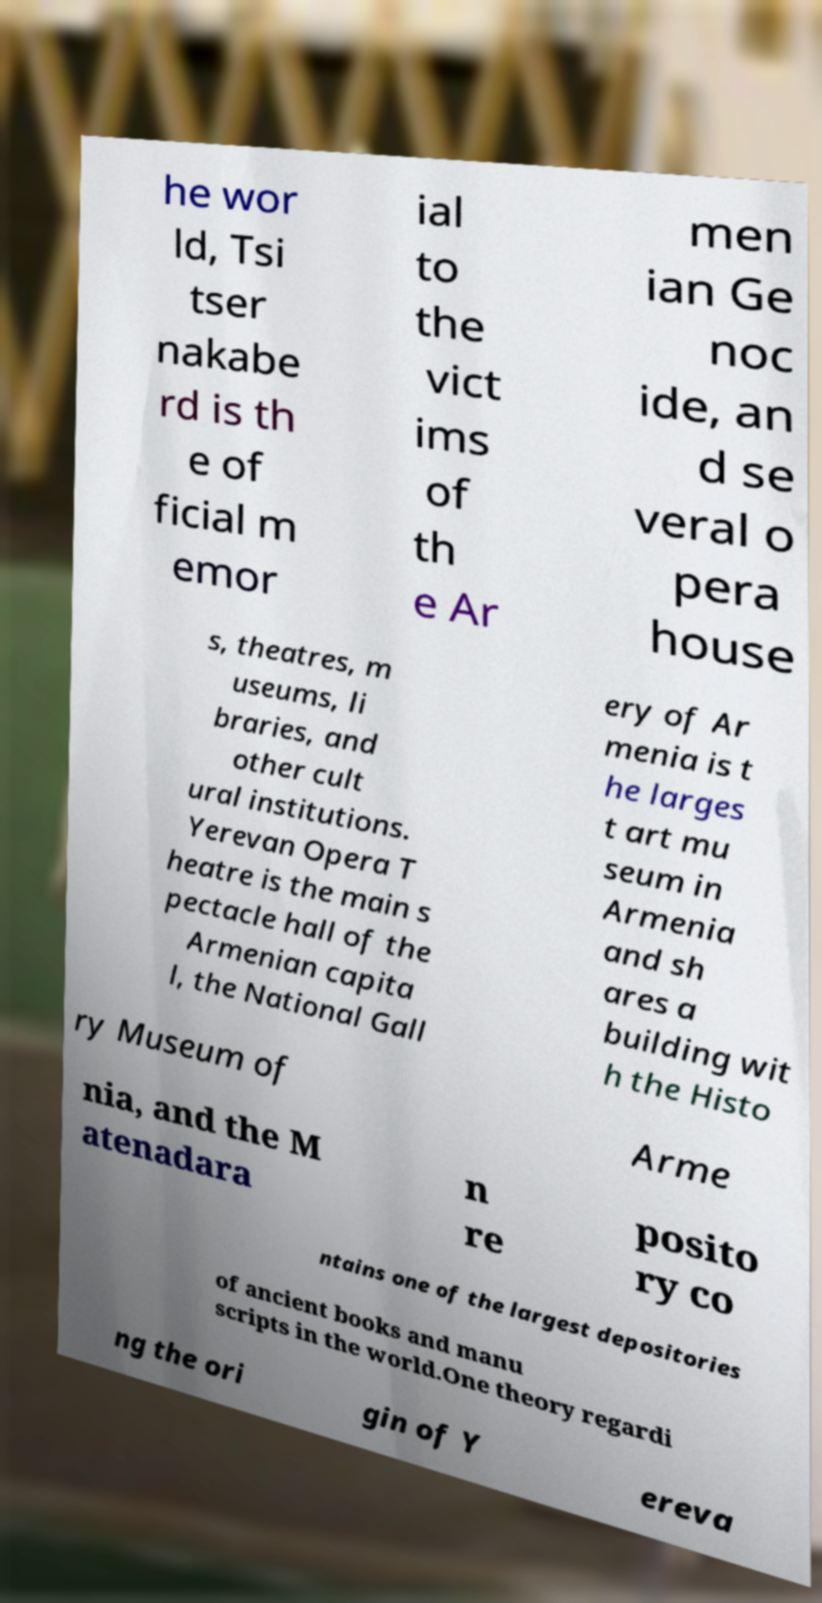I need the written content from this picture converted into text. Can you do that? he wor ld, Tsi tser nakabe rd is th e of ficial m emor ial to the vict ims of th e Ar men ian Ge noc ide, an d se veral o pera house s, theatres, m useums, li braries, and other cult ural institutions. Yerevan Opera T heatre is the main s pectacle hall of the Armenian capita l, the National Gall ery of Ar menia is t he larges t art mu seum in Armenia and sh ares a building wit h the Histo ry Museum of Arme nia, and the M atenadara n re posito ry co ntains one of the largest depositories of ancient books and manu scripts in the world.One theory regardi ng the ori gin of Y ereva 